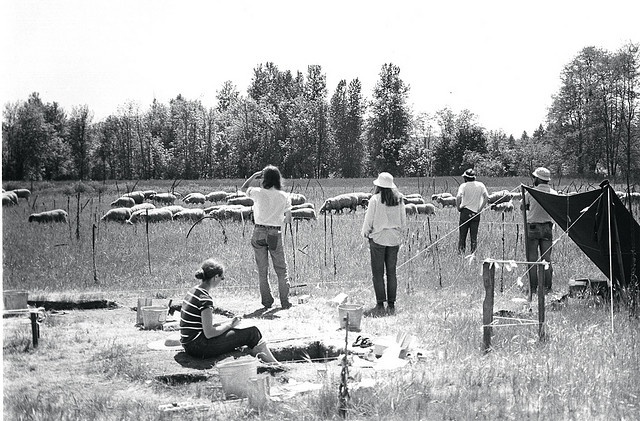Describe the objects in this image and their specific colors. I can see sheep in white, darkgray, lightgray, gray, and black tones, people in white, gray, darkgray, lightgray, and black tones, people in white, darkgray, black, lightgray, and gray tones, people in white, black, gray, darkgray, and lightgray tones, and people in white, black, gray, darkgray, and lightgray tones in this image. 